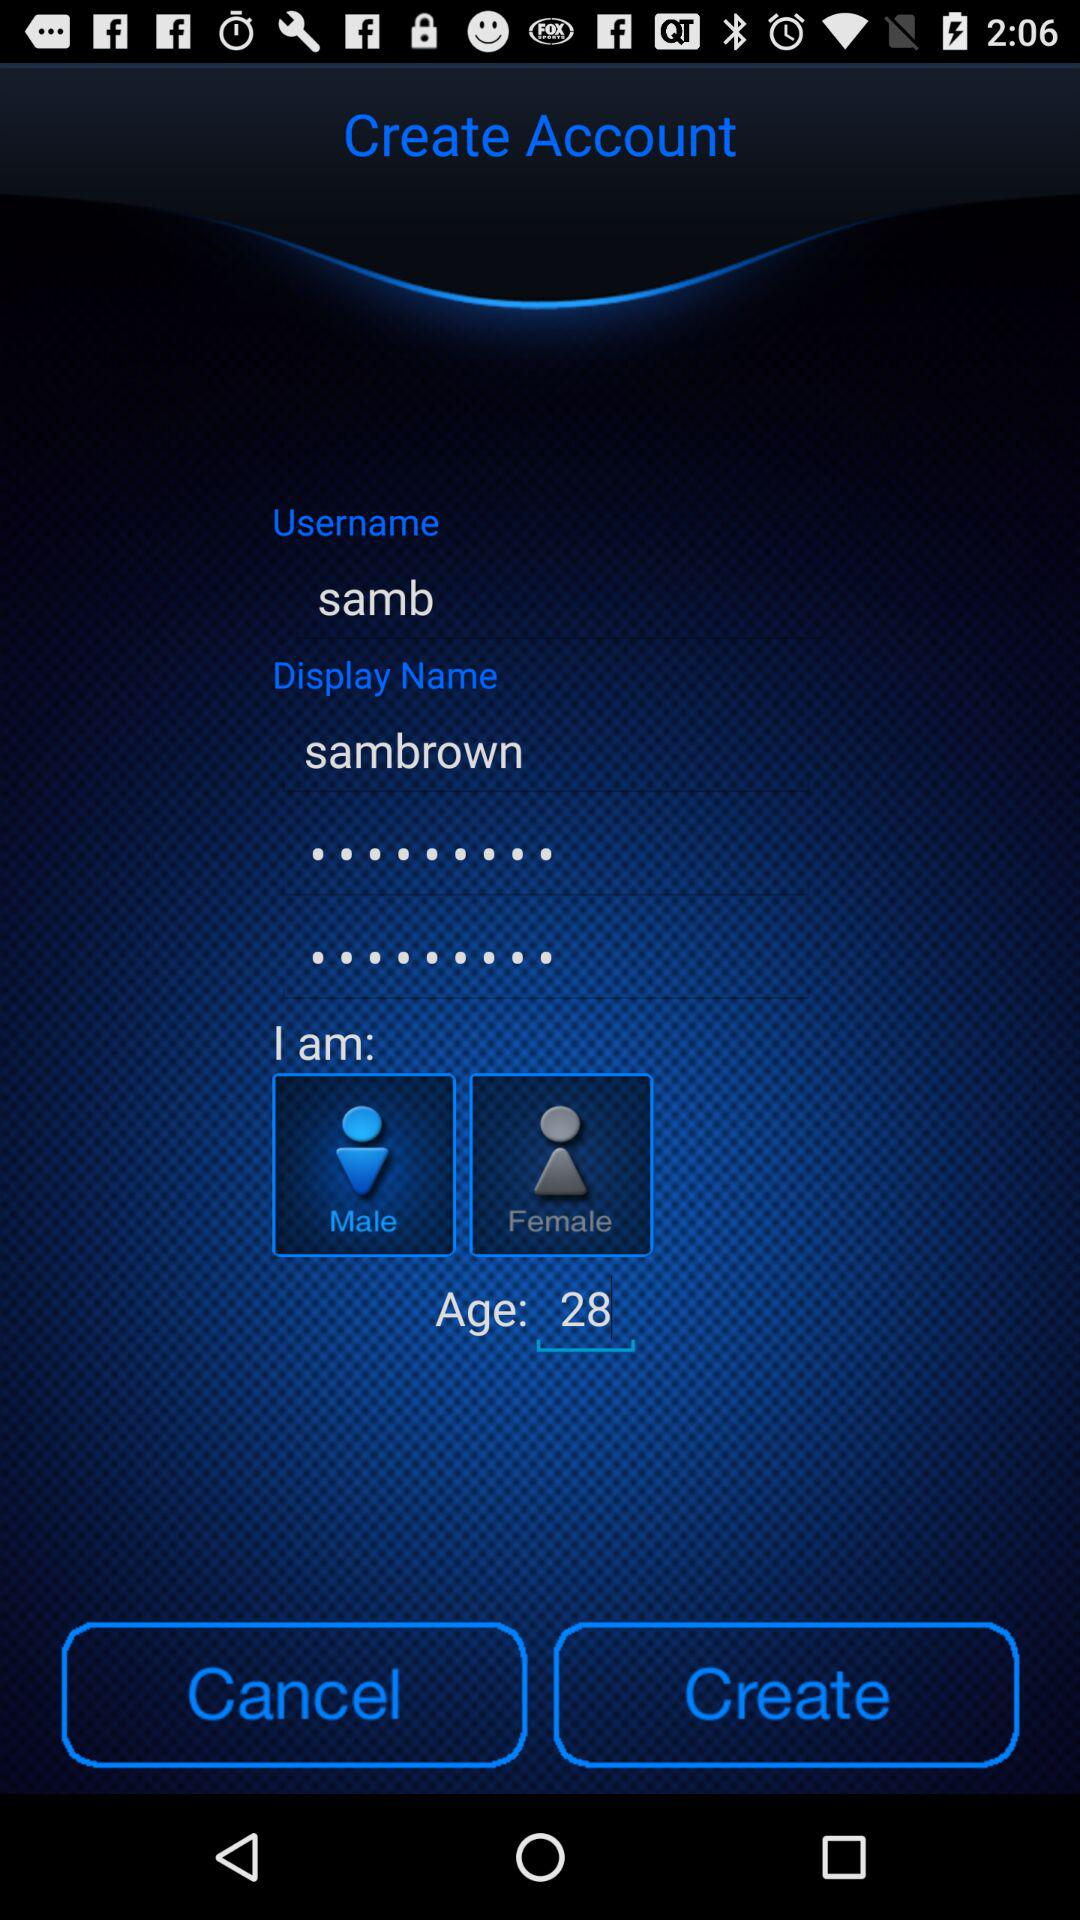What gender is selected? The selected gender is Male. 